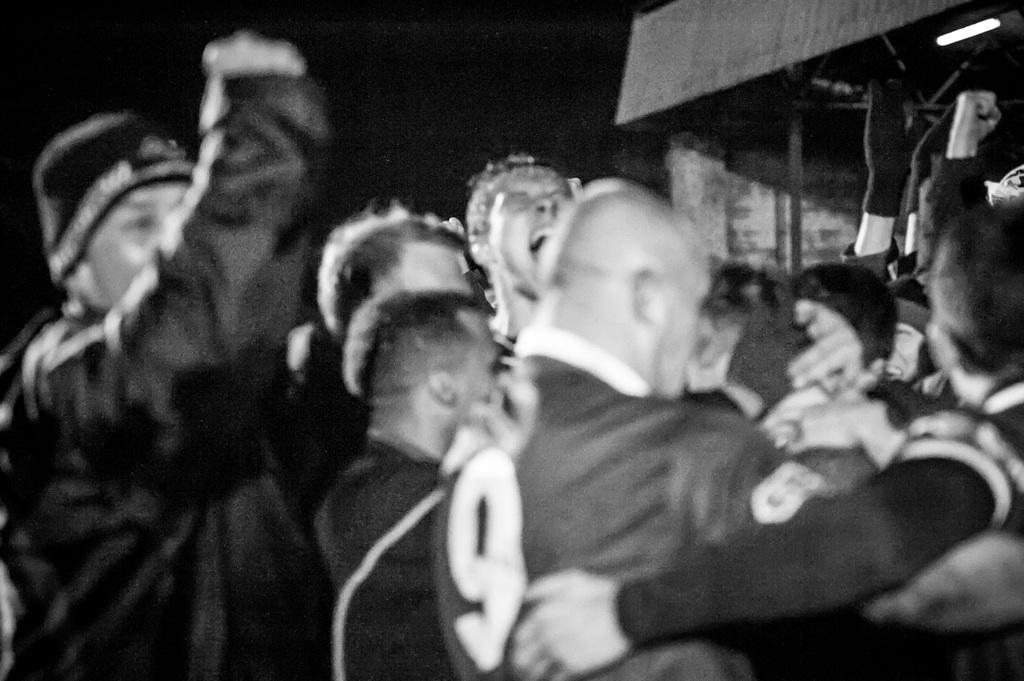What is the color scheme of the image? The image is black and white. How many people are in the image? There are a few people in the image. What objects can be seen in the image besides the people? There are poles, a light, and a shed visible in the image. What part of the natural environment is visible in the image? The sky is visible in the image. What type of kettle is being used to express fear in the image? There is no kettle present in the image, and no one is expressing fear. What agreement was reached between the people in the image? There is no indication of an agreement or discussion between the people in the image. 